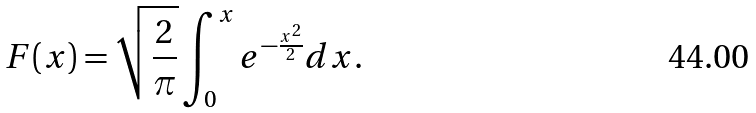Convert formula to latex. <formula><loc_0><loc_0><loc_500><loc_500>F ( x ) = \sqrt { \frac { 2 } { \pi } } \int _ { 0 } ^ { x } e ^ { - \frac { x ^ { 2 } } { 2 } } d x .</formula> 